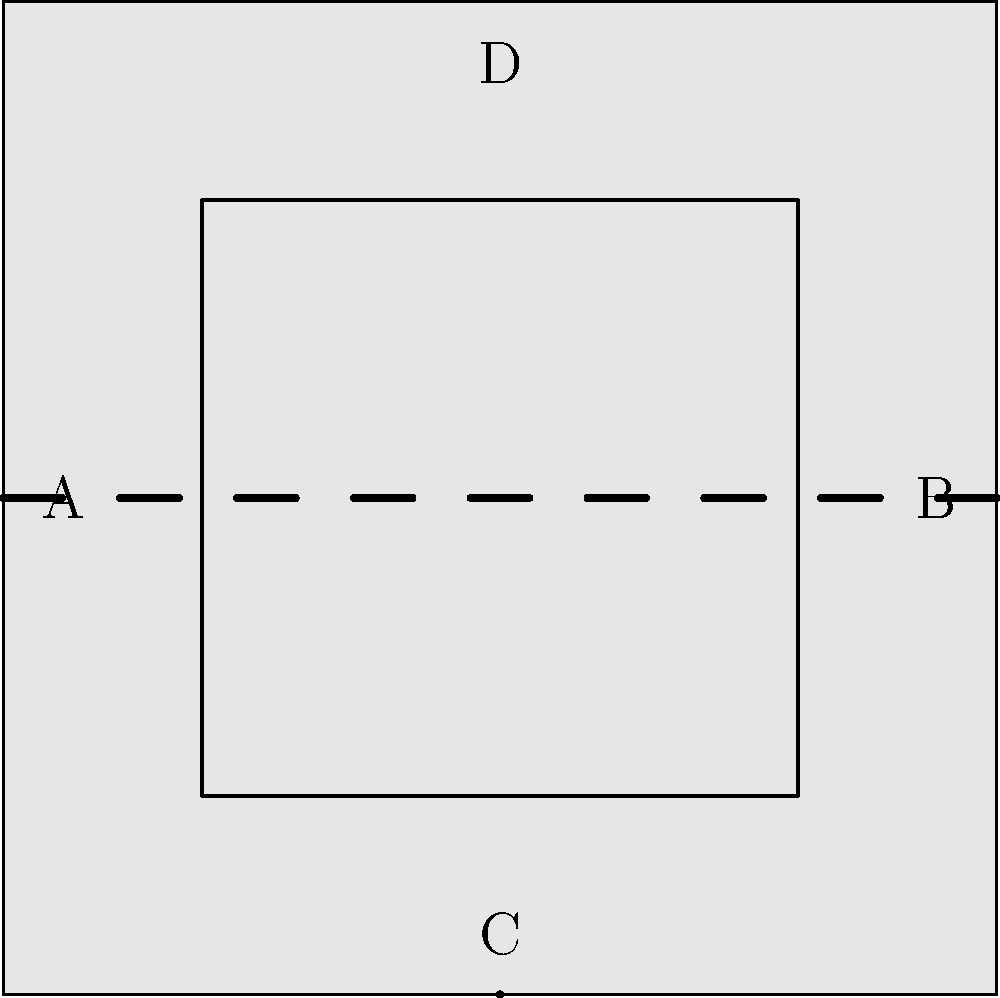In this simplified representation of a traditional Palauan tattoo design, how many lines of symmetry are present? To determine the number of lines of symmetry in this traditional Palauan tattoo design, let's analyze the figure step-by-step:

1. First, we observe that the design is a square shape within a larger square.

2. The vertical dashed line passing through the center of the square (from point D to point C) divides the design into two identical halves. This is our first line of symmetry.

3. The horizontal dashed line passing through the center of the square (from point A to point B) also divides the design into two identical halves. This is our second line of symmetry.

4. Due to the square shape of both the outer and inner designs, we can also identify two diagonal lines of symmetry:
   a. From the top-left corner to the bottom-right corner
   b. From the top-right corner to the bottom-left corner

5. These diagonal lines would also divide the design into identical halves if drawn.

Therefore, we can conclude that this simplified representation of a traditional Palauan tattoo design has a total of 4 lines of symmetry: vertical, horizontal, and two diagonal lines.

This high degree of symmetry is characteristic of many traditional Palauan tattoo designs, reflecting the importance of balance and harmony in Palauan culture.
Answer: 4 